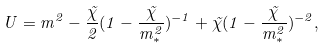Convert formula to latex. <formula><loc_0><loc_0><loc_500><loc_500>U = m ^ { 2 } - \frac { \tilde { \chi } } { 2 } ( 1 - \frac { \tilde { \chi } } { m _ { * } ^ { 2 } } ) ^ { - 1 } + \tilde { \chi } ( 1 - \frac { \tilde { \chi } } { m _ { * } ^ { 2 } } ) ^ { - 2 } ,</formula> 